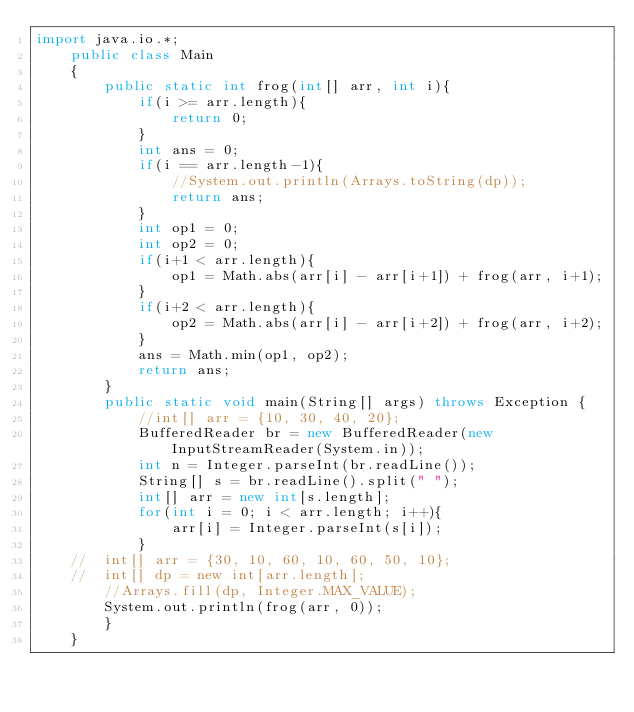<code> <loc_0><loc_0><loc_500><loc_500><_Java_>import java.io.*;
    public class Main
    {
        public static int frog(int[] arr, int i){
            if(i >= arr.length){
                return 0;
            }
            int ans = 0;
            if(i == arr.length-1){
                //System.out.println(Arrays.toString(dp));
                return ans;
            }
            int op1 = 0;
            int op2 = 0;
            if(i+1 < arr.length){
                op1 = Math.abs(arr[i] - arr[i+1]) + frog(arr, i+1);
            }
            if(i+2 < arr.length){
                op2 = Math.abs(arr[i] - arr[i+2]) + frog(arr, i+2);
            }
            ans = Math.min(op1, op2);
            return ans;
        }
    	public static void main(String[] args) throws Exception {
    	    //int[] arr = {10, 30, 40, 20};
    	    BufferedReader br = new BufferedReader(new InputStreamReader(System.in));
    	    int n = Integer.parseInt(br.readLine());
    	    String[] s = br.readLine().split(" ");
    	    int[] arr = new int[s.length];
    	    for(int i = 0; i < arr.length; i++){
    	        arr[i] = Integer.parseInt(s[i]);
    	    }
    // 	int[] arr = {30, 10, 60, 10, 60, 50, 10};
    // 	int[] dp = new int[arr.length];
    	//Arrays.fill(dp, Integer.MAX_VALUE);
    	System.out.println(frog(arr, 0));
    	}
    }
</code> 